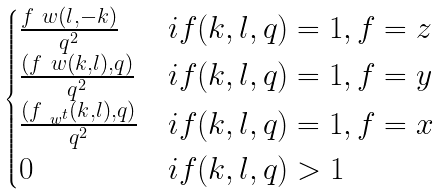Convert formula to latex. <formula><loc_0><loc_0><loc_500><loc_500>\begin{cases} \frac { f _ { \ } w ( l , - k ) } { q ^ { 2 } } & i f ( k , l , q ) = 1 , f = z \\ \frac { ( f _ { \ } w ( k , l ) , q ) } { q ^ { 2 } } & i f ( k , l , q ) = 1 , f = y \\ \frac { ( f _ { \ w ^ { t } } ( k , l ) , q ) } { q ^ { 2 } } & i f ( k , l , q ) = 1 , f = x \\ 0 & i f ( k , l , q ) > 1 \end{cases}</formula> 